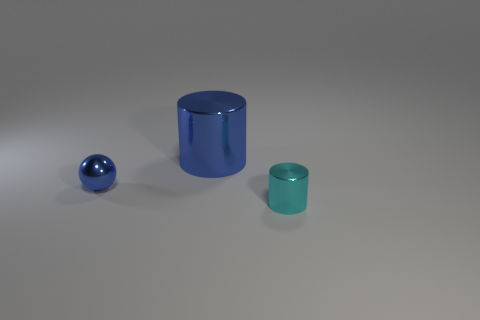How many metal balls are the same color as the big shiny thing?
Provide a short and direct response. 1. What number of small things are either shiny cylinders or metallic spheres?
Offer a terse response. 2. What size is the object that is the same color as the metal sphere?
Provide a succinct answer. Large. Are there any other big blue cylinders made of the same material as the blue cylinder?
Provide a succinct answer. No. There is a small object right of the big blue metallic cylinder; what is its material?
Offer a terse response. Metal. There is a cylinder behind the tiny metal sphere; is its color the same as the small shiny thing to the left of the tiny cyan shiny cylinder?
Your response must be concise. Yes. There is a metallic thing that is the same size as the sphere; what color is it?
Make the answer very short. Cyan. What number of other objects are the same shape as the small cyan shiny thing?
Offer a terse response. 1. There is a blue metal thing that is right of the tiny blue metallic ball; what size is it?
Provide a short and direct response. Large. There is a small blue metal thing behind the cyan shiny object; how many blue objects are behind it?
Ensure brevity in your answer.  1. 